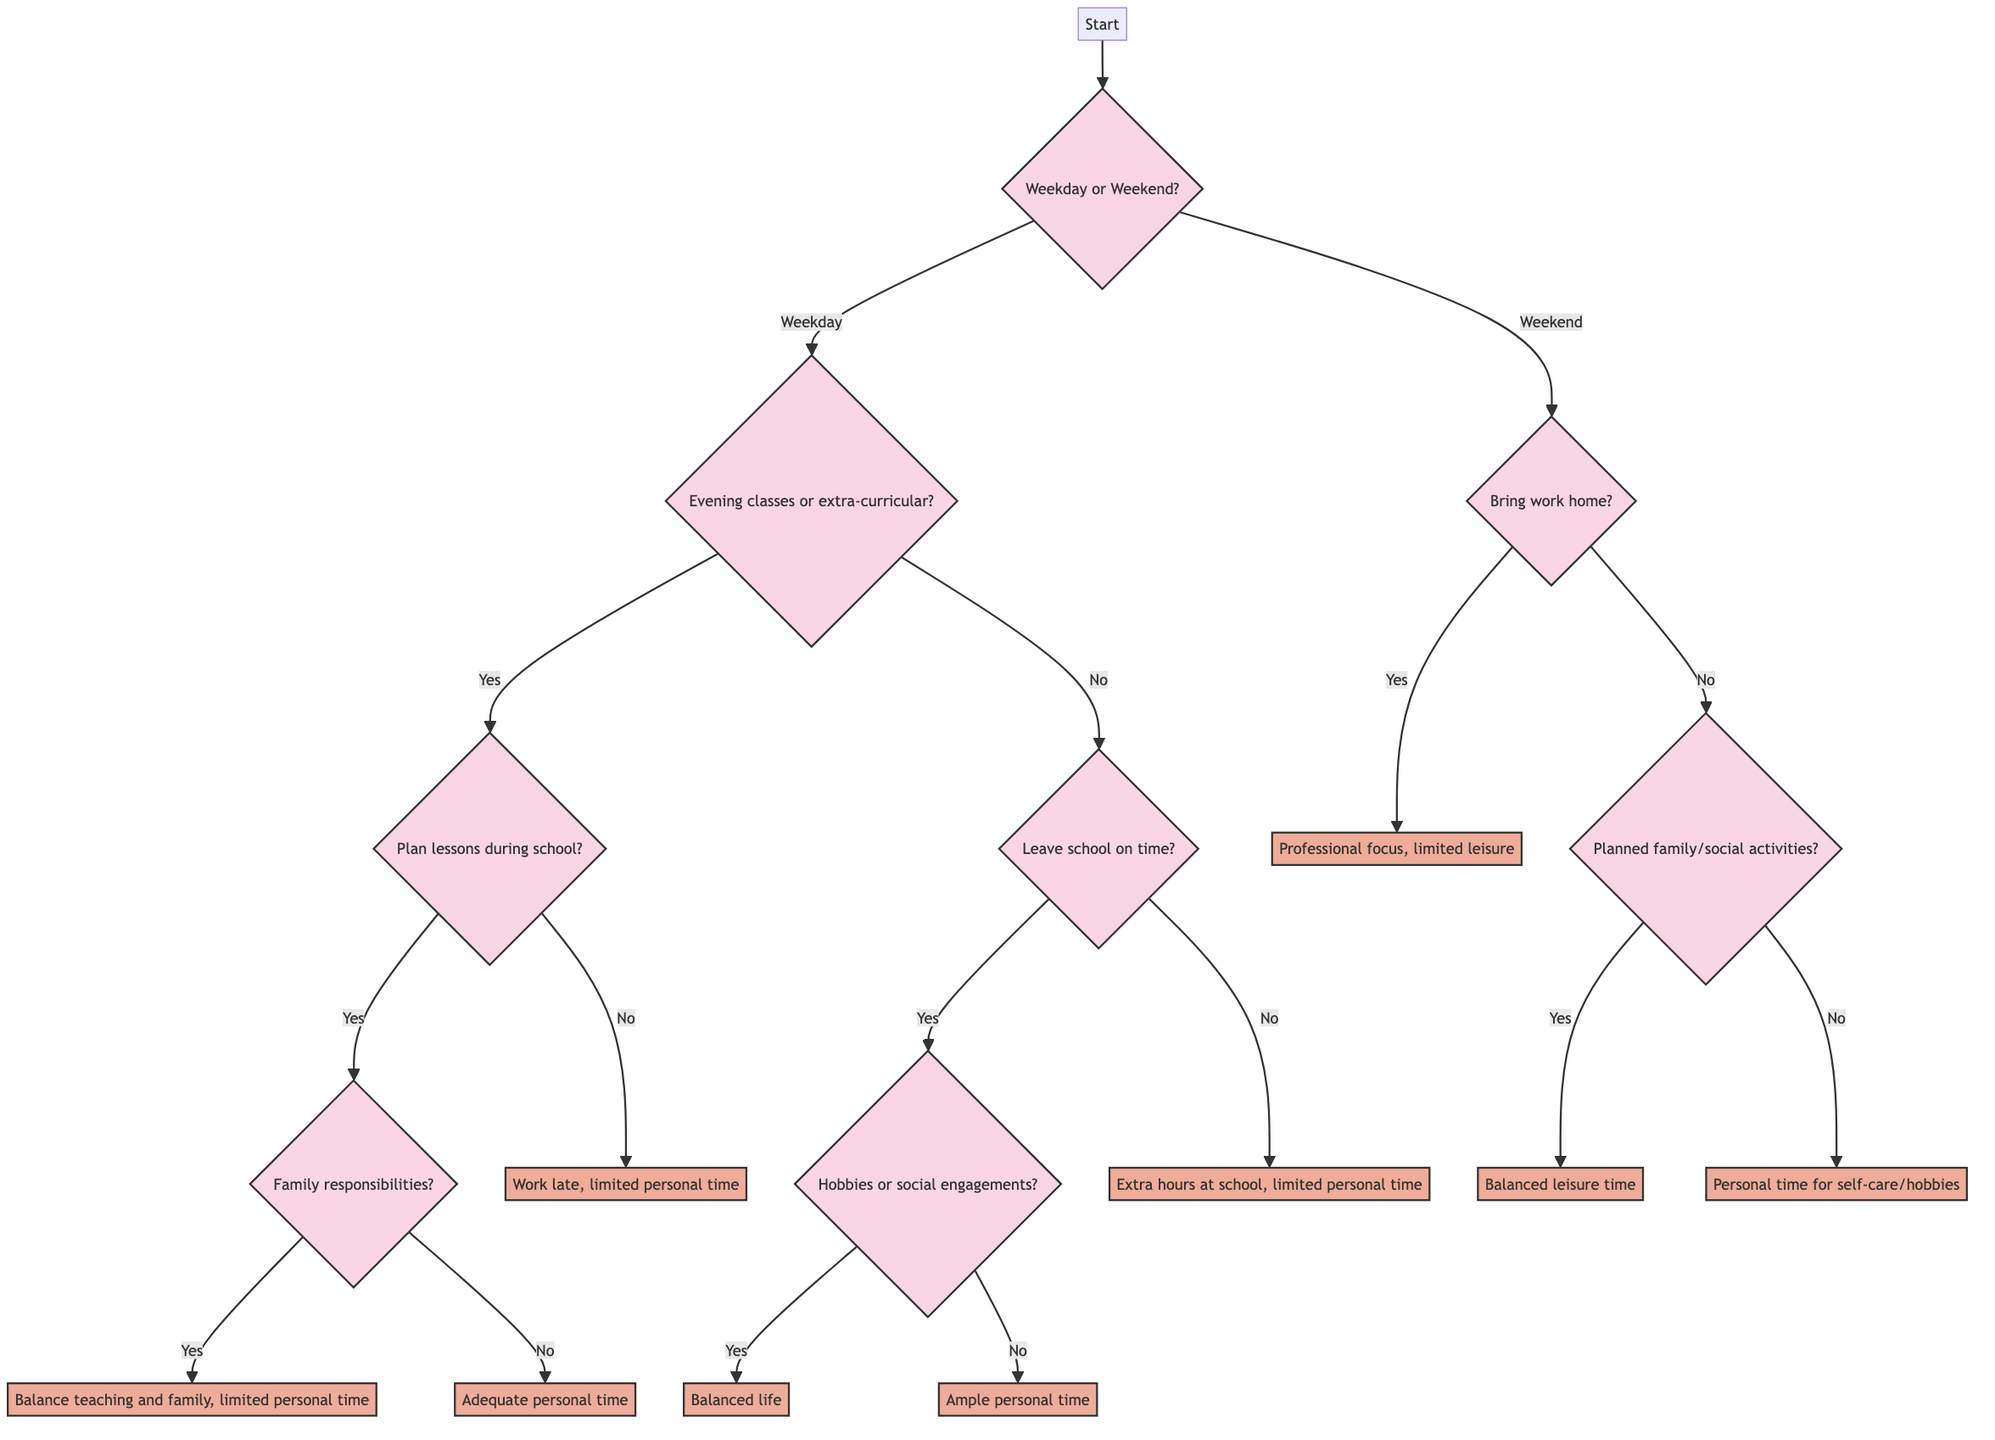What is the first question asked in the diagram? The first question in the diagram is whether it is a weekday or a weekend. This is indicated at the starting point of the decision tree, where the flow leads to two branches based on the time of the week.
Answer: Is it a weekday or a weekend? How many decisions does the diagram contain? The diagram contains seven decisions that are reached based on different paths through the questions. These decisions outline the outcomes based on various circumstances a teacher faces regarding work-life balance.
Answer: Seven What happens if a teacher has evening classes and plans lessons during school hours but has family responsibilities? In this scenario, the decision tree indicates that the teacher will achieve a balance between teaching and family commitments, but this results in limited personal time. To reach this conclusion, one would follow the pathway starting from weekday, evening classes, planning lessons during school hours, and then assessing family responsibilities.
Answer: Balance between teaching and family, but limited personal time What is the outcome if the teacher can leave school on time and has hobbies? If the teacher can leave school on time and has hobbies, the outcome is a balanced life that includes work, social activities, and personal time. This can be determined by tracing the pathway from the question about leaving on time to the question about hobbies or social engagements.
Answer: Balanced life with work, social, and personal time What is the teacher's situation if they do not bring work home on the weekend and have planned social activities? If the teacher does not bring work home on the weekend and has planned social activities, the outcome is a balanced leisure time, indicating that the teacher has time for both relaxation and social interaction. This conclusion comes from navigating through the questions about bringing work home and then checking for planned activities.
Answer: Balanced leisure time with family or social interactions What are the consequences if a teacher works late into the evening due to lesson planning? The consequence in this case is that the teacher has limited personal time. To arrive at this answer, one must follow the path from weekday, evening classes, and then note that there is no lesson planning during school hours.
Answer: Teacher works late into the evening planning lessons, limited personal time 